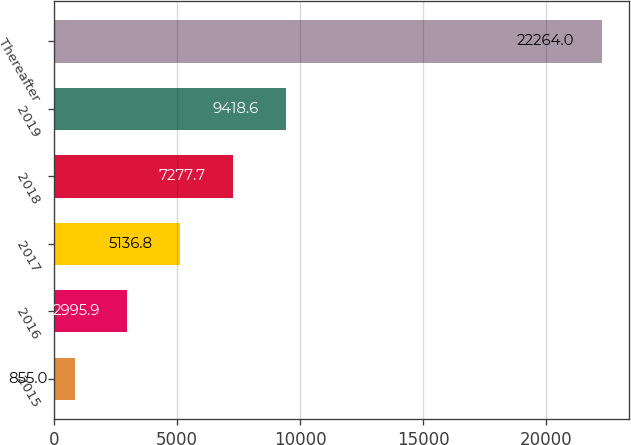Convert chart to OTSL. <chart><loc_0><loc_0><loc_500><loc_500><bar_chart><fcel>2015<fcel>2016<fcel>2017<fcel>2018<fcel>2019<fcel>Thereafter<nl><fcel>855<fcel>2995.9<fcel>5136.8<fcel>7277.7<fcel>9418.6<fcel>22264<nl></chart> 